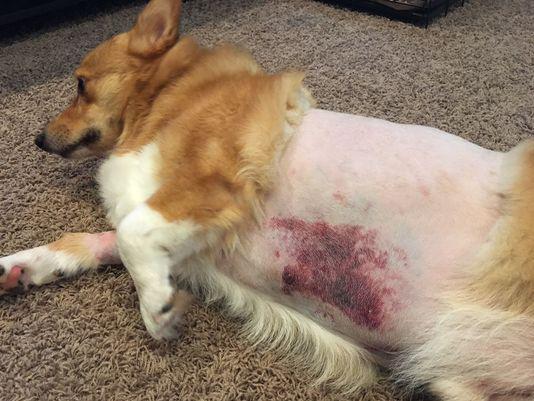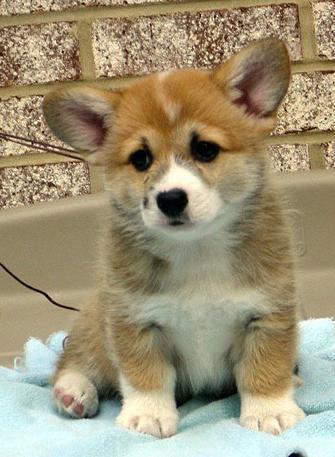The first image is the image on the left, the second image is the image on the right. Considering the images on both sides, is "One puppy is sitting in each image." valid? Answer yes or no. No. The first image is the image on the left, the second image is the image on the right. Analyze the images presented: Is the assertion "There is one sitting puppy in the image on the left." valid? Answer yes or no. No. 